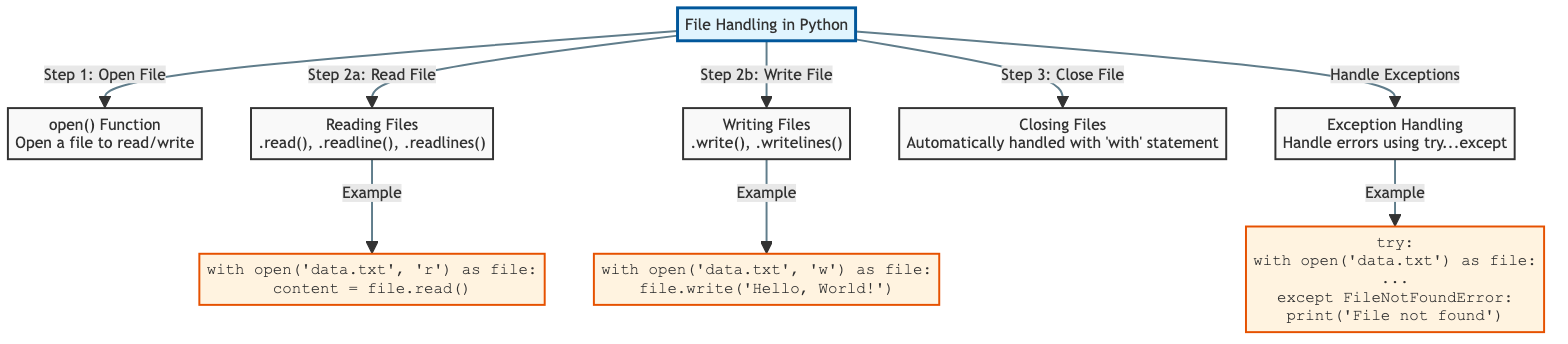What is the first step in file handling according to the diagram? The diagram indicates that the first step in file handling is to open the file, which is represented by the node labeled "open() Function." This node is directly connected to the main node, indicating it is the starting point.
Answer: open File Which method is used to read an entire file? The diagram shows that the method used to read an entire file is the .read() method, which is part of the "Reading Files" node. This is clearly labeled in the diagram, showing that .read() is one of the options available under this category.
Answer: .read() What is the last step in file handling? The last step in file handling according to the diagram is to close the file, represented by the node labeled "Closing Files." This node is the final point in the flowchart sequence, confirming it as the last step after opening and reading or writing the file.
Answer: close File How many methods for reading files are listed in the diagram? The diagram lists three methods for reading files: .read(), .readline(), and .readlines(). Each method is explicitly shown under the "Reading Files" node, indicating the different ways a file can be read.
Answer: three What action should be taken when a file is not found? The diagram suggests using exception handling to deal with file errors, specifically indicating that a FileNotFoundError can be caught using a try...except block. This implies that an error message should be printed when the file is not found.
Answer: print('File not found') What is the purpose of the 'with' statement in file handling? The 'with' statement is utilized in file handling to ensure proper management of file resources. The diagram indicates that it automatically handles file closing, making it easier to avoid resource leaks by ensuring files are closed after their block is executed.
Answer: Automatically handled with 'with' statement Which programming construct is used for error management in file operations? The diagram highlights that the try...except block is the construct utilized for handling exceptions in file operations. It is shown under the "Exception Handling" node, indicating its role in managing potential errors that may arise during file handling.
Answer: try...except 